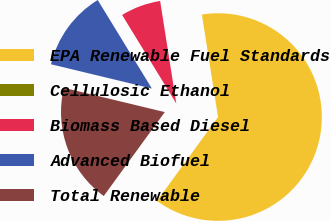Convert chart to OTSL. <chart><loc_0><loc_0><loc_500><loc_500><pie_chart><fcel>EPA Renewable Fuel Standards<fcel>Cellulosic Ethanol<fcel>Biomass Based Diesel<fcel>Advanced Biofuel<fcel>Total Renewable<nl><fcel>62.49%<fcel>0.0%<fcel>6.25%<fcel>12.5%<fcel>18.75%<nl></chart> 